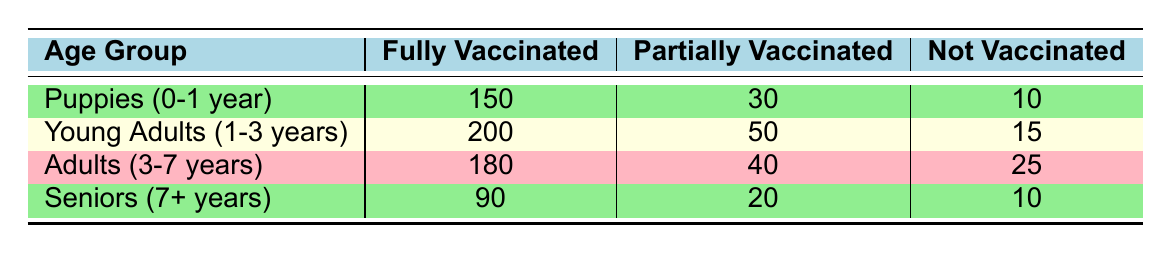What is the total number of Puppies that are fully vaccinated? From the table, the count of Puppies (0-1 year) that are fully vaccinated is 150.
Answer: 150 What is the total count of dogs in the Young Adults age group? To find the total for Young Adults (1-3 years), we need to add the counts of all vaccination statuses: 200 (fully vaccinated) + 50 (partially vaccinated) + 15 (not vaccinated) = 265.
Answer: 265 How many Seniors are not vaccinated? Referring to the table, the number of Seniors (7+ years) not vaccinated is 10.
Answer: 10 Among the age groups, which group has the highest count of fully vaccinated dogs? The fully vaccinated counts are: Puppies (150), Young Adults (200), Adults (180), and Seniors (90). Young Adults have the highest count at 200.
Answer: Young Adults What is the percentage of Puppies that are fully vaccinated? The total count of Puppies (0-1 year) is 150 (fully vaccinated) + 30 (partially vaccinated) + 10 (not vaccinated) = 190. The percentage of fully vaccinated Puppies is (150/190) * 100 = 78.95%.
Answer: 78.95% Is it true that more Puppies are fully vaccinated than Seniors? The fully vaccinated Puppies count is 150, while the fully vaccinated Seniors count is 90. Since 150 is greater than 90, the statement is true.
Answer: Yes What is the difference in the number of partially vaccinated dogs between the Young Adults and Adults age groups? The partially vaccinated counts for Young Adults (50) and Adults (40) have a difference of 50 - 40 = 10.
Answer: 10 If you combine the counts of fully vaccinated and partially vaccinated dogs for the Adults age group, what is the total? The count for Adults (3-7 years) that are fully vaccinated is 180 and partially vaccinated is 40. Adding these gives 180 + 40 = 220.
Answer: 220 Which age group has the least number of dogs that are vaccines? The counts for Not Vaccinated dogs are: Puppies (10), Young Adults (15), Adults (25), Seniors (10). Both Puppies and Seniors have the least at 10.
Answer: Puppies and Seniors 